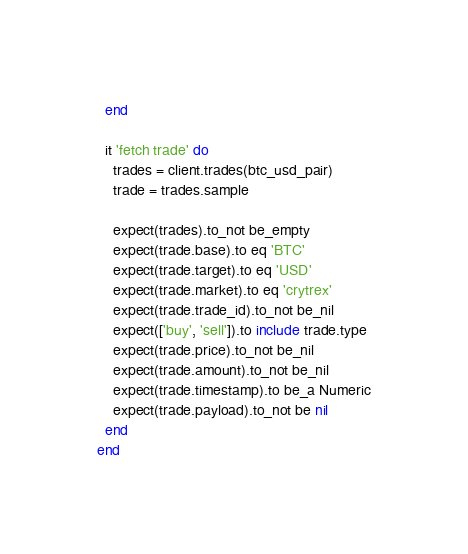Convert code to text. <code><loc_0><loc_0><loc_500><loc_500><_Ruby_>  end

  it 'fetch trade' do
    trades = client.trades(btc_usd_pair)
    trade = trades.sample

    expect(trades).to_not be_empty
    expect(trade.base).to eq 'BTC'
    expect(trade.target).to eq 'USD'
    expect(trade.market).to eq 'crytrex'
    expect(trade.trade_id).to_not be_nil
    expect(['buy', 'sell']).to include trade.type
    expect(trade.price).to_not be_nil
    expect(trade.amount).to_not be_nil
    expect(trade.timestamp).to be_a Numeric
    expect(trade.payload).to_not be nil
  end
end
</code> 